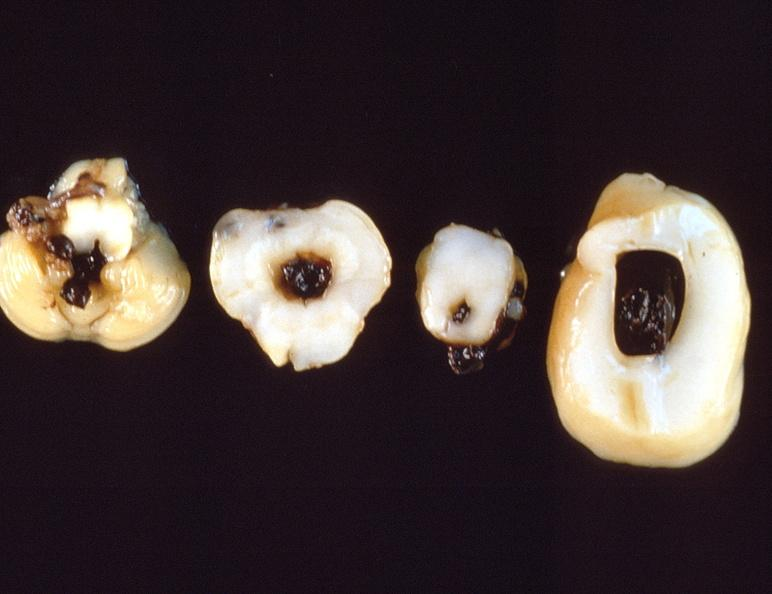does muscle show intraventricular hemorrhage, neonate brain?
Answer the question using a single word or phrase. No 